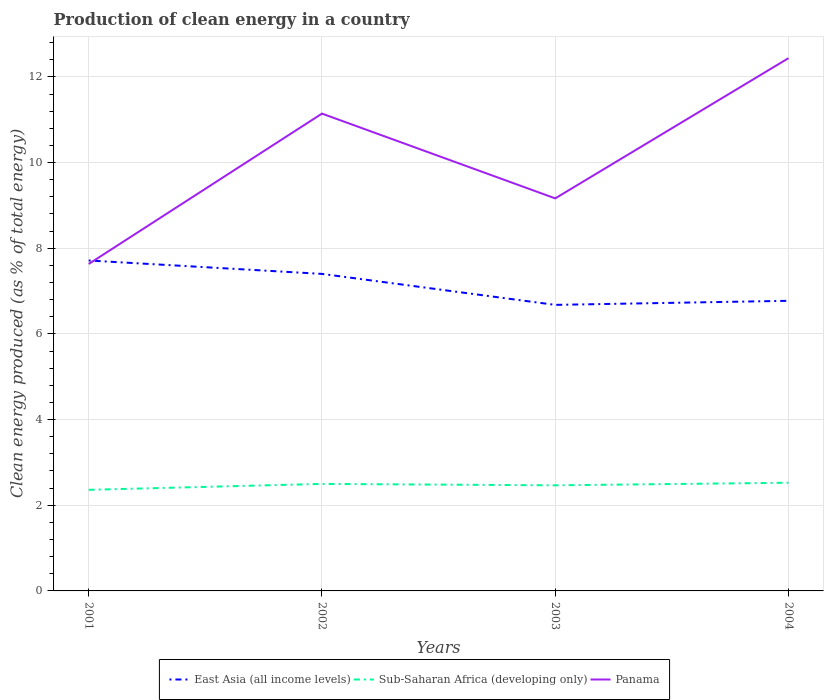How many different coloured lines are there?
Ensure brevity in your answer.  3. Is the number of lines equal to the number of legend labels?
Your response must be concise. Yes. Across all years, what is the maximum percentage of clean energy produced in Panama?
Your response must be concise. 7.63. In which year was the percentage of clean energy produced in East Asia (all income levels) maximum?
Your answer should be compact. 2003. What is the total percentage of clean energy produced in East Asia (all income levels) in the graph?
Keep it short and to the point. 0.94. What is the difference between the highest and the second highest percentage of clean energy produced in Sub-Saharan Africa (developing only)?
Offer a terse response. 0.17. What is the difference between the highest and the lowest percentage of clean energy produced in East Asia (all income levels)?
Your answer should be very brief. 2. How many lines are there?
Ensure brevity in your answer.  3. How many years are there in the graph?
Ensure brevity in your answer.  4. What is the difference between two consecutive major ticks on the Y-axis?
Ensure brevity in your answer.  2. Does the graph contain any zero values?
Provide a short and direct response. No. How many legend labels are there?
Give a very brief answer. 3. How are the legend labels stacked?
Ensure brevity in your answer.  Horizontal. What is the title of the graph?
Your response must be concise. Production of clean energy in a country. Does "Tonga" appear as one of the legend labels in the graph?
Provide a short and direct response. No. What is the label or title of the X-axis?
Provide a short and direct response. Years. What is the label or title of the Y-axis?
Make the answer very short. Clean energy produced (as % of total energy). What is the Clean energy produced (as % of total energy) in East Asia (all income levels) in 2001?
Provide a short and direct response. 7.71. What is the Clean energy produced (as % of total energy) in Sub-Saharan Africa (developing only) in 2001?
Your answer should be very brief. 2.36. What is the Clean energy produced (as % of total energy) of Panama in 2001?
Give a very brief answer. 7.63. What is the Clean energy produced (as % of total energy) in East Asia (all income levels) in 2002?
Your answer should be very brief. 7.4. What is the Clean energy produced (as % of total energy) of Sub-Saharan Africa (developing only) in 2002?
Give a very brief answer. 2.5. What is the Clean energy produced (as % of total energy) of Panama in 2002?
Provide a succinct answer. 11.14. What is the Clean energy produced (as % of total energy) in East Asia (all income levels) in 2003?
Give a very brief answer. 6.68. What is the Clean energy produced (as % of total energy) of Sub-Saharan Africa (developing only) in 2003?
Give a very brief answer. 2.47. What is the Clean energy produced (as % of total energy) of Panama in 2003?
Make the answer very short. 9.16. What is the Clean energy produced (as % of total energy) in East Asia (all income levels) in 2004?
Your response must be concise. 6.77. What is the Clean energy produced (as % of total energy) in Sub-Saharan Africa (developing only) in 2004?
Offer a very short reply. 2.53. What is the Clean energy produced (as % of total energy) in Panama in 2004?
Your answer should be compact. 12.44. Across all years, what is the maximum Clean energy produced (as % of total energy) of East Asia (all income levels)?
Your answer should be compact. 7.71. Across all years, what is the maximum Clean energy produced (as % of total energy) in Sub-Saharan Africa (developing only)?
Your answer should be compact. 2.53. Across all years, what is the maximum Clean energy produced (as % of total energy) of Panama?
Your answer should be very brief. 12.44. Across all years, what is the minimum Clean energy produced (as % of total energy) in East Asia (all income levels)?
Keep it short and to the point. 6.68. Across all years, what is the minimum Clean energy produced (as % of total energy) of Sub-Saharan Africa (developing only)?
Keep it short and to the point. 2.36. Across all years, what is the minimum Clean energy produced (as % of total energy) in Panama?
Provide a succinct answer. 7.63. What is the total Clean energy produced (as % of total energy) of East Asia (all income levels) in the graph?
Make the answer very short. 28.57. What is the total Clean energy produced (as % of total energy) in Sub-Saharan Africa (developing only) in the graph?
Offer a terse response. 9.85. What is the total Clean energy produced (as % of total energy) of Panama in the graph?
Provide a short and direct response. 40.38. What is the difference between the Clean energy produced (as % of total energy) of East Asia (all income levels) in 2001 and that in 2002?
Ensure brevity in your answer.  0.31. What is the difference between the Clean energy produced (as % of total energy) in Sub-Saharan Africa (developing only) in 2001 and that in 2002?
Offer a terse response. -0.14. What is the difference between the Clean energy produced (as % of total energy) of Panama in 2001 and that in 2002?
Your response must be concise. -3.51. What is the difference between the Clean energy produced (as % of total energy) of East Asia (all income levels) in 2001 and that in 2003?
Provide a short and direct response. 1.04. What is the difference between the Clean energy produced (as % of total energy) of Sub-Saharan Africa (developing only) in 2001 and that in 2003?
Offer a terse response. -0.11. What is the difference between the Clean energy produced (as % of total energy) in Panama in 2001 and that in 2003?
Offer a terse response. -1.53. What is the difference between the Clean energy produced (as % of total energy) of East Asia (all income levels) in 2001 and that in 2004?
Your response must be concise. 0.94. What is the difference between the Clean energy produced (as % of total energy) of Sub-Saharan Africa (developing only) in 2001 and that in 2004?
Ensure brevity in your answer.  -0.17. What is the difference between the Clean energy produced (as % of total energy) of Panama in 2001 and that in 2004?
Offer a very short reply. -4.8. What is the difference between the Clean energy produced (as % of total energy) in East Asia (all income levels) in 2002 and that in 2003?
Your answer should be very brief. 0.72. What is the difference between the Clean energy produced (as % of total energy) of Sub-Saharan Africa (developing only) in 2002 and that in 2003?
Provide a short and direct response. 0.03. What is the difference between the Clean energy produced (as % of total energy) of Panama in 2002 and that in 2003?
Provide a short and direct response. 1.98. What is the difference between the Clean energy produced (as % of total energy) in East Asia (all income levels) in 2002 and that in 2004?
Provide a succinct answer. 0.63. What is the difference between the Clean energy produced (as % of total energy) of Sub-Saharan Africa (developing only) in 2002 and that in 2004?
Offer a terse response. -0.03. What is the difference between the Clean energy produced (as % of total energy) in Panama in 2002 and that in 2004?
Make the answer very short. -1.29. What is the difference between the Clean energy produced (as % of total energy) in East Asia (all income levels) in 2003 and that in 2004?
Your answer should be very brief. -0.1. What is the difference between the Clean energy produced (as % of total energy) of Sub-Saharan Africa (developing only) in 2003 and that in 2004?
Your response must be concise. -0.06. What is the difference between the Clean energy produced (as % of total energy) of Panama in 2003 and that in 2004?
Your answer should be compact. -3.27. What is the difference between the Clean energy produced (as % of total energy) in East Asia (all income levels) in 2001 and the Clean energy produced (as % of total energy) in Sub-Saharan Africa (developing only) in 2002?
Offer a terse response. 5.22. What is the difference between the Clean energy produced (as % of total energy) in East Asia (all income levels) in 2001 and the Clean energy produced (as % of total energy) in Panama in 2002?
Keep it short and to the point. -3.43. What is the difference between the Clean energy produced (as % of total energy) in Sub-Saharan Africa (developing only) in 2001 and the Clean energy produced (as % of total energy) in Panama in 2002?
Make the answer very short. -8.78. What is the difference between the Clean energy produced (as % of total energy) of East Asia (all income levels) in 2001 and the Clean energy produced (as % of total energy) of Sub-Saharan Africa (developing only) in 2003?
Your answer should be very brief. 5.25. What is the difference between the Clean energy produced (as % of total energy) of East Asia (all income levels) in 2001 and the Clean energy produced (as % of total energy) of Panama in 2003?
Your answer should be compact. -1.45. What is the difference between the Clean energy produced (as % of total energy) of Sub-Saharan Africa (developing only) in 2001 and the Clean energy produced (as % of total energy) of Panama in 2003?
Provide a short and direct response. -6.8. What is the difference between the Clean energy produced (as % of total energy) in East Asia (all income levels) in 2001 and the Clean energy produced (as % of total energy) in Sub-Saharan Africa (developing only) in 2004?
Your response must be concise. 5.19. What is the difference between the Clean energy produced (as % of total energy) of East Asia (all income levels) in 2001 and the Clean energy produced (as % of total energy) of Panama in 2004?
Provide a succinct answer. -4.72. What is the difference between the Clean energy produced (as % of total energy) in Sub-Saharan Africa (developing only) in 2001 and the Clean energy produced (as % of total energy) in Panama in 2004?
Your answer should be very brief. -10.08. What is the difference between the Clean energy produced (as % of total energy) in East Asia (all income levels) in 2002 and the Clean energy produced (as % of total energy) in Sub-Saharan Africa (developing only) in 2003?
Your response must be concise. 4.94. What is the difference between the Clean energy produced (as % of total energy) of East Asia (all income levels) in 2002 and the Clean energy produced (as % of total energy) of Panama in 2003?
Your answer should be compact. -1.76. What is the difference between the Clean energy produced (as % of total energy) of Sub-Saharan Africa (developing only) in 2002 and the Clean energy produced (as % of total energy) of Panama in 2003?
Offer a very short reply. -6.67. What is the difference between the Clean energy produced (as % of total energy) in East Asia (all income levels) in 2002 and the Clean energy produced (as % of total energy) in Sub-Saharan Africa (developing only) in 2004?
Offer a terse response. 4.88. What is the difference between the Clean energy produced (as % of total energy) in East Asia (all income levels) in 2002 and the Clean energy produced (as % of total energy) in Panama in 2004?
Your response must be concise. -5.04. What is the difference between the Clean energy produced (as % of total energy) of Sub-Saharan Africa (developing only) in 2002 and the Clean energy produced (as % of total energy) of Panama in 2004?
Provide a short and direct response. -9.94. What is the difference between the Clean energy produced (as % of total energy) in East Asia (all income levels) in 2003 and the Clean energy produced (as % of total energy) in Sub-Saharan Africa (developing only) in 2004?
Give a very brief answer. 4.15. What is the difference between the Clean energy produced (as % of total energy) in East Asia (all income levels) in 2003 and the Clean energy produced (as % of total energy) in Panama in 2004?
Provide a short and direct response. -5.76. What is the difference between the Clean energy produced (as % of total energy) of Sub-Saharan Africa (developing only) in 2003 and the Clean energy produced (as % of total energy) of Panama in 2004?
Keep it short and to the point. -9.97. What is the average Clean energy produced (as % of total energy) in East Asia (all income levels) per year?
Provide a short and direct response. 7.14. What is the average Clean energy produced (as % of total energy) of Sub-Saharan Africa (developing only) per year?
Your answer should be very brief. 2.46. What is the average Clean energy produced (as % of total energy) of Panama per year?
Keep it short and to the point. 10.09. In the year 2001, what is the difference between the Clean energy produced (as % of total energy) of East Asia (all income levels) and Clean energy produced (as % of total energy) of Sub-Saharan Africa (developing only)?
Your answer should be very brief. 5.35. In the year 2001, what is the difference between the Clean energy produced (as % of total energy) of East Asia (all income levels) and Clean energy produced (as % of total energy) of Panama?
Your answer should be compact. 0.08. In the year 2001, what is the difference between the Clean energy produced (as % of total energy) in Sub-Saharan Africa (developing only) and Clean energy produced (as % of total energy) in Panama?
Provide a short and direct response. -5.27. In the year 2002, what is the difference between the Clean energy produced (as % of total energy) in East Asia (all income levels) and Clean energy produced (as % of total energy) in Sub-Saharan Africa (developing only)?
Make the answer very short. 4.9. In the year 2002, what is the difference between the Clean energy produced (as % of total energy) of East Asia (all income levels) and Clean energy produced (as % of total energy) of Panama?
Keep it short and to the point. -3.74. In the year 2002, what is the difference between the Clean energy produced (as % of total energy) in Sub-Saharan Africa (developing only) and Clean energy produced (as % of total energy) in Panama?
Offer a terse response. -8.64. In the year 2003, what is the difference between the Clean energy produced (as % of total energy) in East Asia (all income levels) and Clean energy produced (as % of total energy) in Sub-Saharan Africa (developing only)?
Your response must be concise. 4.21. In the year 2003, what is the difference between the Clean energy produced (as % of total energy) of East Asia (all income levels) and Clean energy produced (as % of total energy) of Panama?
Ensure brevity in your answer.  -2.49. In the year 2003, what is the difference between the Clean energy produced (as % of total energy) of Sub-Saharan Africa (developing only) and Clean energy produced (as % of total energy) of Panama?
Your response must be concise. -6.7. In the year 2004, what is the difference between the Clean energy produced (as % of total energy) in East Asia (all income levels) and Clean energy produced (as % of total energy) in Sub-Saharan Africa (developing only)?
Provide a succinct answer. 4.25. In the year 2004, what is the difference between the Clean energy produced (as % of total energy) of East Asia (all income levels) and Clean energy produced (as % of total energy) of Panama?
Your answer should be very brief. -5.66. In the year 2004, what is the difference between the Clean energy produced (as % of total energy) in Sub-Saharan Africa (developing only) and Clean energy produced (as % of total energy) in Panama?
Offer a very short reply. -9.91. What is the ratio of the Clean energy produced (as % of total energy) in East Asia (all income levels) in 2001 to that in 2002?
Your answer should be very brief. 1.04. What is the ratio of the Clean energy produced (as % of total energy) in Sub-Saharan Africa (developing only) in 2001 to that in 2002?
Make the answer very short. 0.94. What is the ratio of the Clean energy produced (as % of total energy) in Panama in 2001 to that in 2002?
Provide a short and direct response. 0.68. What is the ratio of the Clean energy produced (as % of total energy) of East Asia (all income levels) in 2001 to that in 2003?
Your answer should be very brief. 1.16. What is the ratio of the Clean energy produced (as % of total energy) of Sub-Saharan Africa (developing only) in 2001 to that in 2003?
Keep it short and to the point. 0.96. What is the ratio of the Clean energy produced (as % of total energy) in Panama in 2001 to that in 2003?
Ensure brevity in your answer.  0.83. What is the ratio of the Clean energy produced (as % of total energy) in East Asia (all income levels) in 2001 to that in 2004?
Make the answer very short. 1.14. What is the ratio of the Clean energy produced (as % of total energy) of Sub-Saharan Africa (developing only) in 2001 to that in 2004?
Offer a terse response. 0.93. What is the ratio of the Clean energy produced (as % of total energy) of Panama in 2001 to that in 2004?
Your response must be concise. 0.61. What is the ratio of the Clean energy produced (as % of total energy) of East Asia (all income levels) in 2002 to that in 2003?
Your response must be concise. 1.11. What is the ratio of the Clean energy produced (as % of total energy) of Sub-Saharan Africa (developing only) in 2002 to that in 2003?
Make the answer very short. 1.01. What is the ratio of the Clean energy produced (as % of total energy) in Panama in 2002 to that in 2003?
Your answer should be compact. 1.22. What is the ratio of the Clean energy produced (as % of total energy) in East Asia (all income levels) in 2002 to that in 2004?
Your answer should be very brief. 1.09. What is the ratio of the Clean energy produced (as % of total energy) of Sub-Saharan Africa (developing only) in 2002 to that in 2004?
Give a very brief answer. 0.99. What is the ratio of the Clean energy produced (as % of total energy) in Panama in 2002 to that in 2004?
Provide a succinct answer. 0.9. What is the ratio of the Clean energy produced (as % of total energy) of East Asia (all income levels) in 2003 to that in 2004?
Give a very brief answer. 0.99. What is the ratio of the Clean energy produced (as % of total energy) in Sub-Saharan Africa (developing only) in 2003 to that in 2004?
Provide a short and direct response. 0.98. What is the ratio of the Clean energy produced (as % of total energy) of Panama in 2003 to that in 2004?
Offer a very short reply. 0.74. What is the difference between the highest and the second highest Clean energy produced (as % of total energy) of East Asia (all income levels)?
Give a very brief answer. 0.31. What is the difference between the highest and the second highest Clean energy produced (as % of total energy) of Sub-Saharan Africa (developing only)?
Keep it short and to the point. 0.03. What is the difference between the highest and the second highest Clean energy produced (as % of total energy) of Panama?
Ensure brevity in your answer.  1.29. What is the difference between the highest and the lowest Clean energy produced (as % of total energy) of East Asia (all income levels)?
Offer a very short reply. 1.04. What is the difference between the highest and the lowest Clean energy produced (as % of total energy) of Sub-Saharan Africa (developing only)?
Give a very brief answer. 0.17. What is the difference between the highest and the lowest Clean energy produced (as % of total energy) in Panama?
Offer a very short reply. 4.8. 